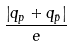<formula> <loc_0><loc_0><loc_500><loc_500>\frac { \left | q _ { p } + q _ { \bar { p } } \right | } { e }</formula> 